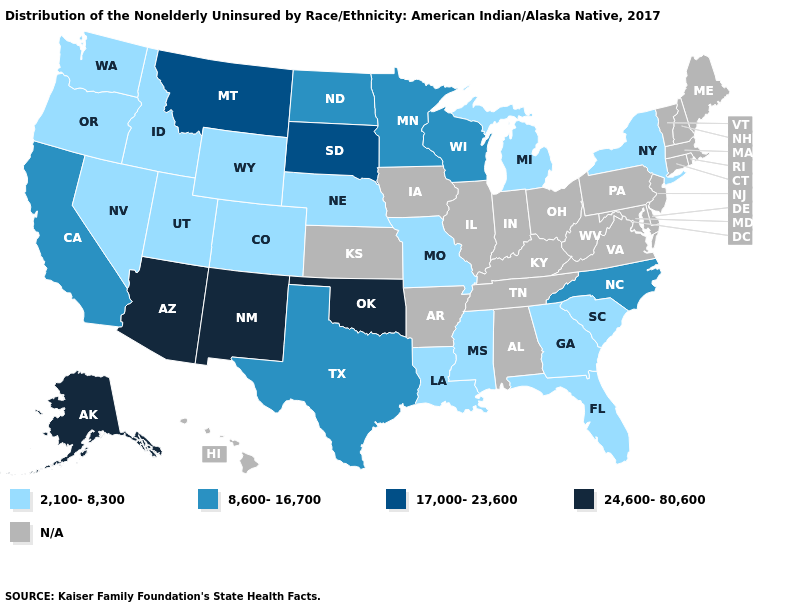Does Florida have the lowest value in the USA?
Answer briefly. Yes. What is the lowest value in the USA?
Quick response, please. 2,100-8,300. What is the value of Pennsylvania?
Short answer required. N/A. What is the value of Indiana?
Give a very brief answer. N/A. What is the lowest value in the South?
Concise answer only. 2,100-8,300. Does Georgia have the highest value in the USA?
Concise answer only. No. What is the lowest value in the USA?
Short answer required. 2,100-8,300. Which states hav the highest value in the South?
Keep it brief. Oklahoma. What is the lowest value in the USA?
Give a very brief answer. 2,100-8,300. Does North Carolina have the highest value in the USA?
Write a very short answer. No. What is the value of Maine?
Write a very short answer. N/A. How many symbols are there in the legend?
Quick response, please. 5. What is the value of Kentucky?
Answer briefly. N/A. What is the value of New Hampshire?
Quick response, please. N/A. Does Oklahoma have the highest value in the South?
Quick response, please. Yes. 